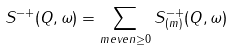Convert formula to latex. <formula><loc_0><loc_0><loc_500><loc_500>S ^ { - + } ( Q , \omega ) = \sum _ { m e v e n \geq 0 } S ^ { - + } _ { ( m ) } ( Q , \omega )</formula> 